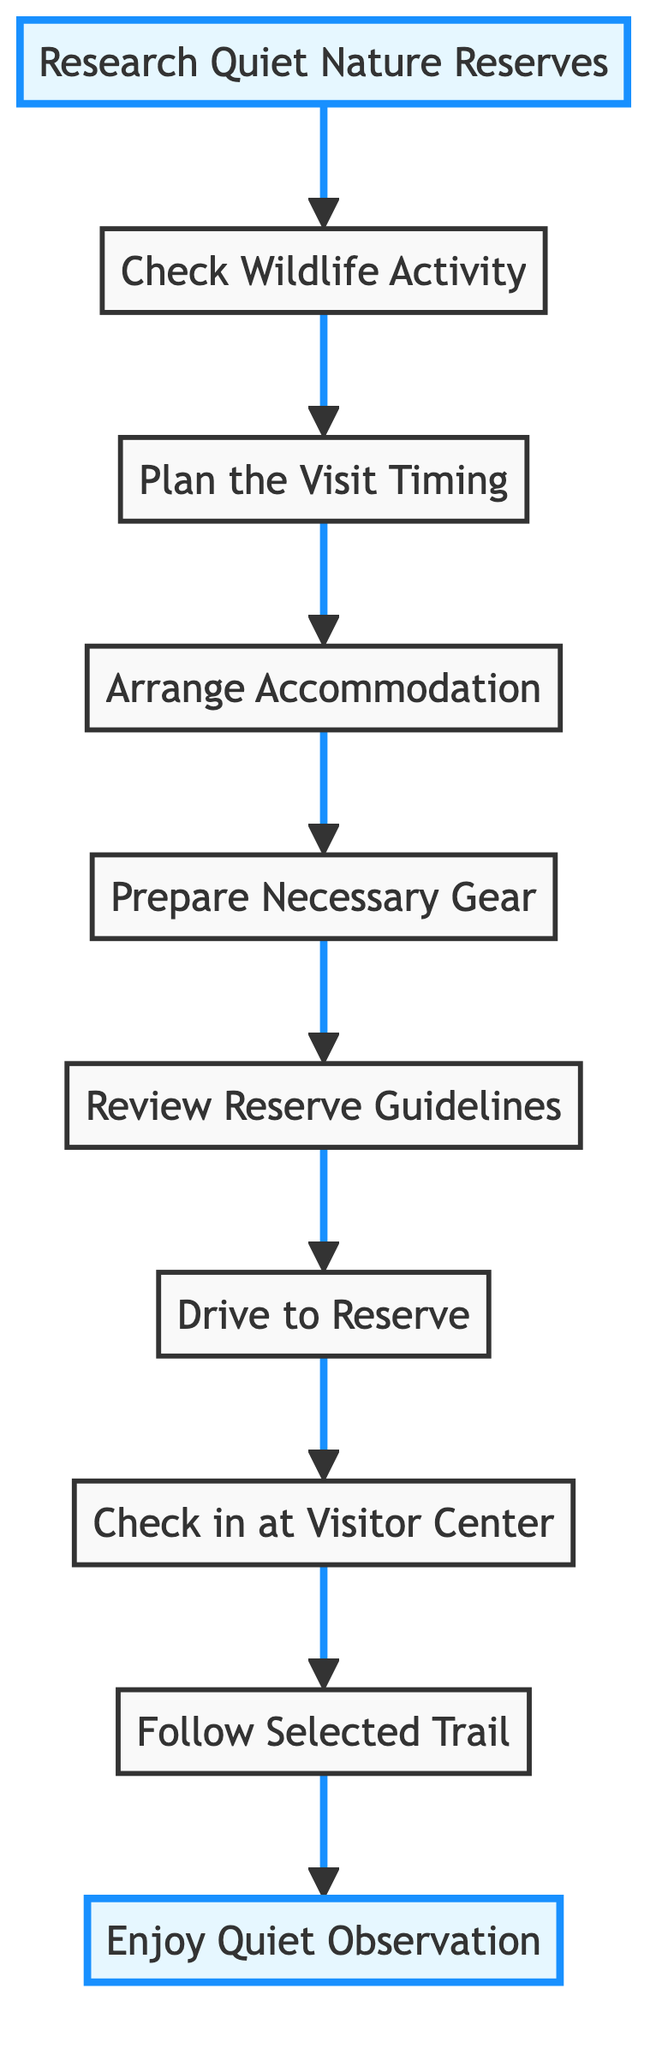What is the first step in planning a visit? The first step listed in the flow chart is "Research Quiet Nature Reserves." This is the starting point of the process shown in the diagram.
Answer: Research Quiet Nature Reserves How many main steps are there in the flowchart? By counting the nodes (steps) shown in the diagram, we find there are a total of 10 main steps from start to finish.
Answer: 10 What step comes after "Check Wildlife Activity"? Following the flow from "Check Wildlife Activity," the next step is "Plan the Visit Timing," which is the third node in the sequence.
Answer: Plan the Visit Timing What is the last step in the visit planning process? The flow diagram concludes with the step "Enjoy Quiet Observation," which is the final activity one should engage in during their visit.
Answer: Enjoy Quiet Observation Which step focuses on packing items? The step that emphasizes preparing to pack essentials is "Prepare Necessary Gear," which highlights the importance of having the right items for comfort and safety.
Answer: Prepare Necessary Gear What is the connection between "Drive to Reserve" and "Check in at Visitor Center"? The flow indicates a direct relationship where "Drive to Reserve" must be completed before proceeding to "Check in at Visitor Center," showing a sequential action.
Answer: Sequential action What should you do after reviewing reserve guidelines? After "Review Reserve Guidelines," the next action to take is "Drive to Reserve," implying the movement towards the nature reserve after understanding the rules.
Answer: Drive to Reserve Which step mentions checking online resources? The step "Research Quiet Nature Reserves" calls for searching online to gather information about suitable nature reserves, specifically focusing on tranquility and low animal density.
Answer: Research Quiet Nature Reserves What is indicated by the highlight color in the flowchart? The highlighted nodes signify the beginning and end of the process, showing where the planning starts with research and concludes with quiet enjoyment.
Answer: Planning start and end points 